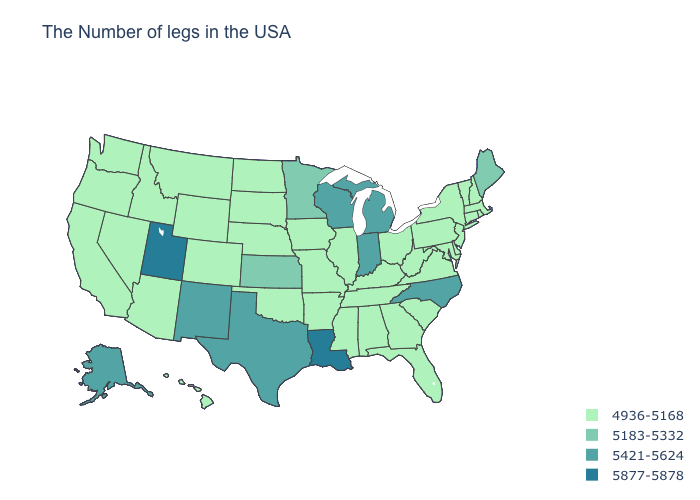Does the first symbol in the legend represent the smallest category?
Keep it brief. Yes. Among the states that border Massachusetts , which have the lowest value?
Quick response, please. Rhode Island, New Hampshire, Vermont, Connecticut, New York. Which states hav the highest value in the Northeast?
Keep it brief. Maine. What is the lowest value in the South?
Write a very short answer. 4936-5168. Which states have the lowest value in the USA?
Write a very short answer. Massachusetts, Rhode Island, New Hampshire, Vermont, Connecticut, New York, New Jersey, Delaware, Maryland, Pennsylvania, Virginia, South Carolina, West Virginia, Ohio, Florida, Georgia, Kentucky, Alabama, Tennessee, Illinois, Mississippi, Missouri, Arkansas, Iowa, Nebraska, Oklahoma, South Dakota, North Dakota, Wyoming, Colorado, Montana, Arizona, Idaho, Nevada, California, Washington, Oregon, Hawaii. Among the states that border Ohio , does Indiana have the lowest value?
Quick response, please. No. Does the map have missing data?
Concise answer only. No. Name the states that have a value in the range 4936-5168?
Concise answer only. Massachusetts, Rhode Island, New Hampshire, Vermont, Connecticut, New York, New Jersey, Delaware, Maryland, Pennsylvania, Virginia, South Carolina, West Virginia, Ohio, Florida, Georgia, Kentucky, Alabama, Tennessee, Illinois, Mississippi, Missouri, Arkansas, Iowa, Nebraska, Oklahoma, South Dakota, North Dakota, Wyoming, Colorado, Montana, Arizona, Idaho, Nevada, California, Washington, Oregon, Hawaii. Which states hav the highest value in the West?
Write a very short answer. Utah. Name the states that have a value in the range 5877-5878?
Write a very short answer. Louisiana, Utah. What is the value of Georgia?
Short answer required. 4936-5168. What is the value of Montana?
Quick response, please. 4936-5168. How many symbols are there in the legend?
Quick response, please. 4. What is the value of Arkansas?
Give a very brief answer. 4936-5168. Which states have the lowest value in the USA?
Be succinct. Massachusetts, Rhode Island, New Hampshire, Vermont, Connecticut, New York, New Jersey, Delaware, Maryland, Pennsylvania, Virginia, South Carolina, West Virginia, Ohio, Florida, Georgia, Kentucky, Alabama, Tennessee, Illinois, Mississippi, Missouri, Arkansas, Iowa, Nebraska, Oklahoma, South Dakota, North Dakota, Wyoming, Colorado, Montana, Arizona, Idaho, Nevada, California, Washington, Oregon, Hawaii. 